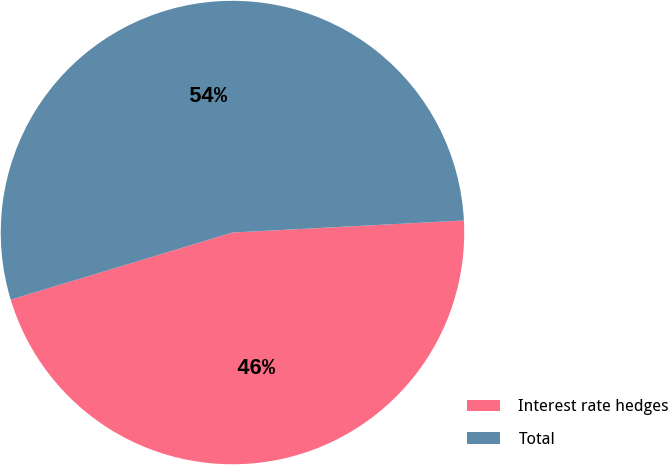Convert chart to OTSL. <chart><loc_0><loc_0><loc_500><loc_500><pie_chart><fcel>Interest rate hedges<fcel>Total<nl><fcel>46.15%<fcel>53.85%<nl></chart> 